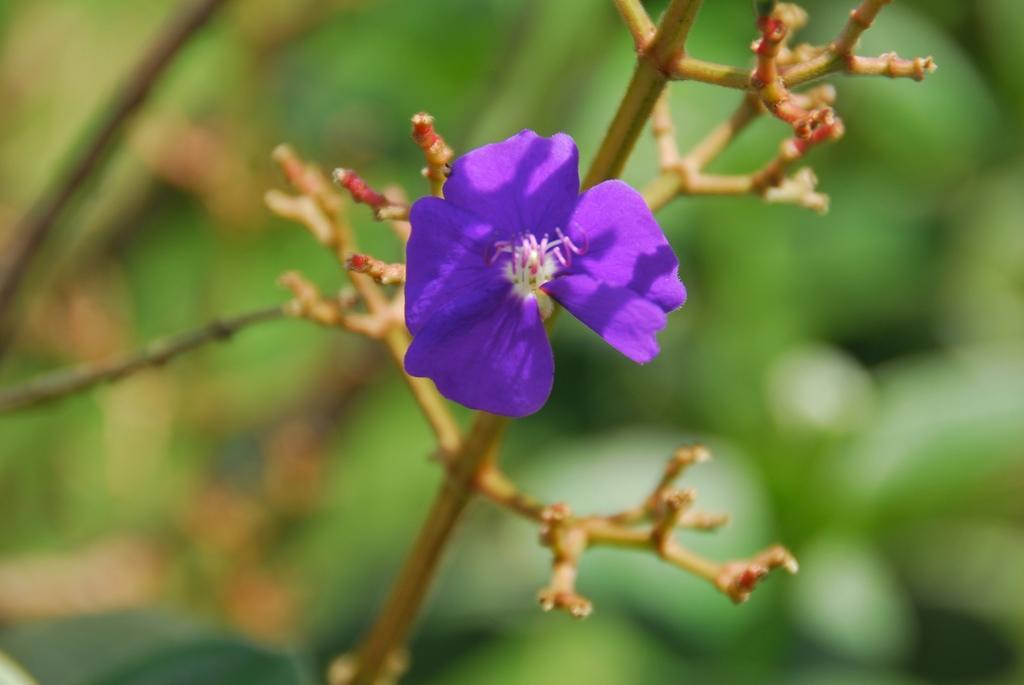Please provide a concise description of this image. In this image, there is branch contains a flower which is color violet. In the background, image is blurred. 